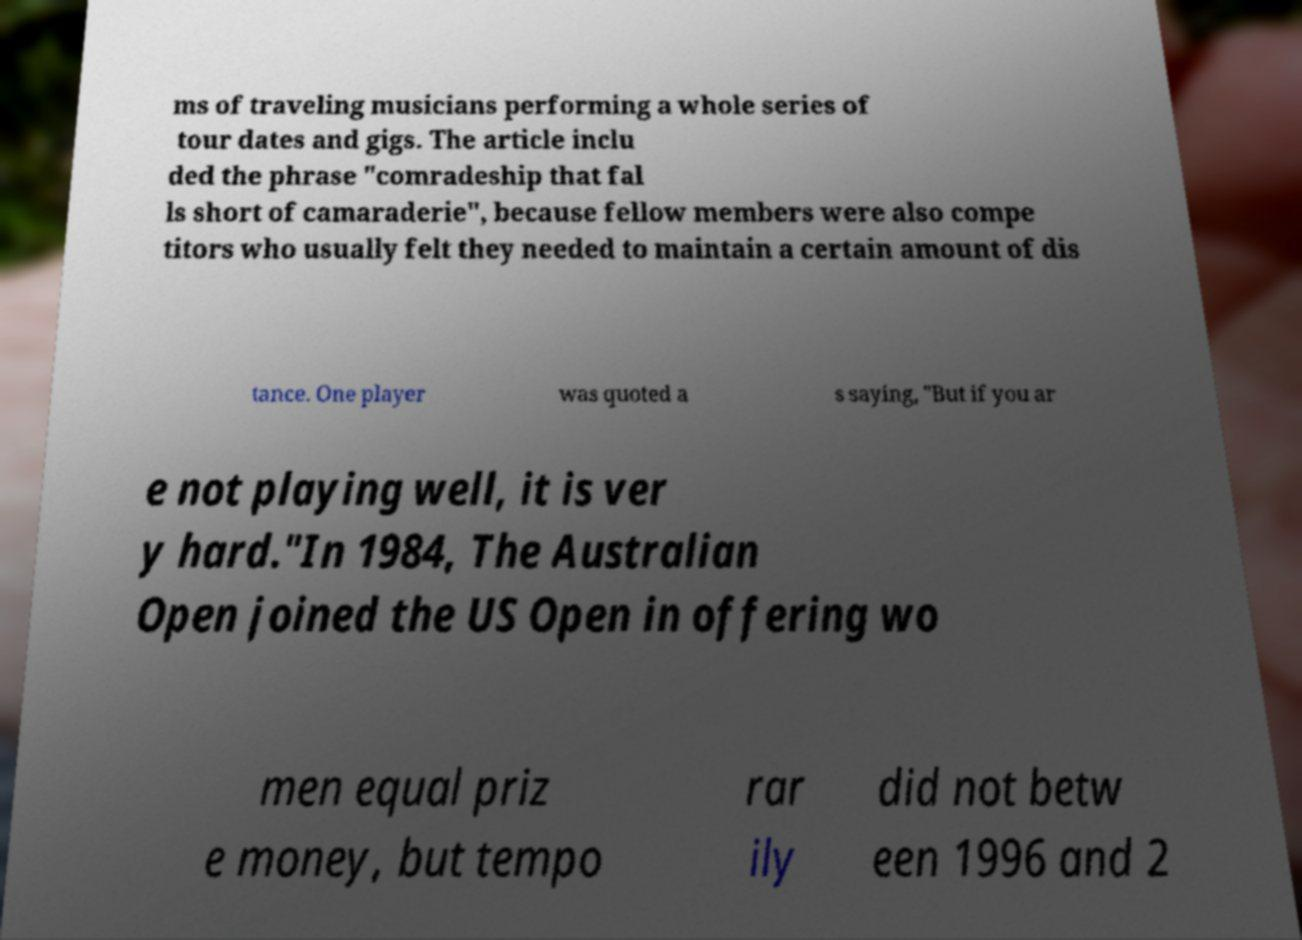Can you read and provide the text displayed in the image?This photo seems to have some interesting text. Can you extract and type it out for me? ms of traveling musicians performing a whole series of tour dates and gigs. The article inclu ded the phrase "comradeship that fal ls short of camaraderie", because fellow members were also compe titors who usually felt they needed to maintain a certain amount of dis tance. One player was quoted a s saying, "But if you ar e not playing well, it is ver y hard."In 1984, The Australian Open joined the US Open in offering wo men equal priz e money, but tempo rar ily did not betw een 1996 and 2 